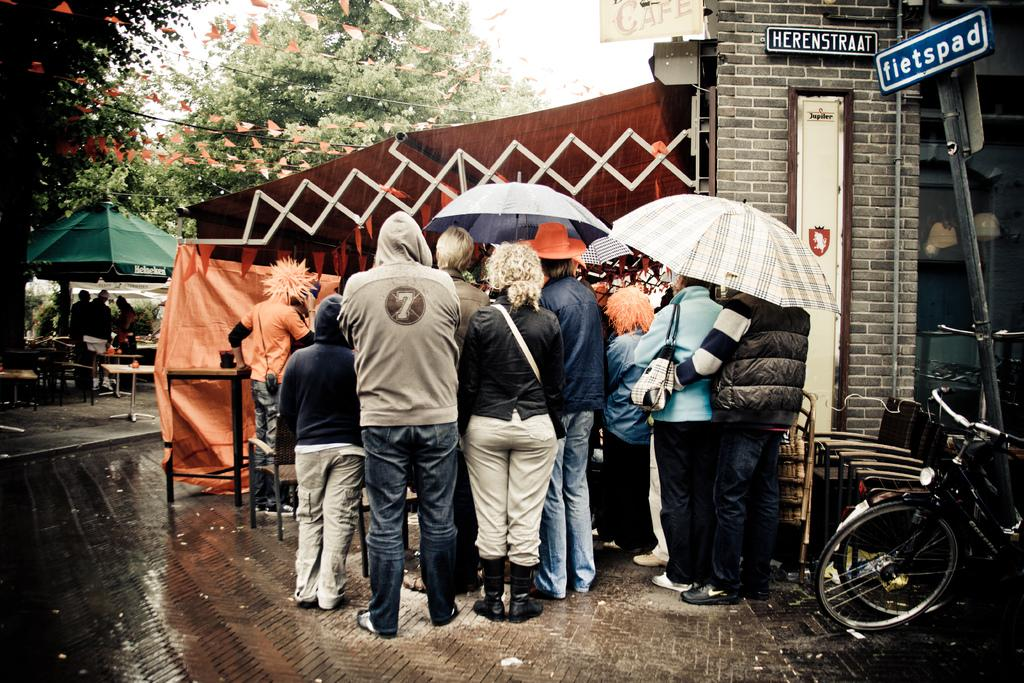What can be seen in the image? There are people, a bicycle, tents, umbrellas, name boards, a wall, various objects, and trees visible in the background. Can you describe the bicycle in the image? The bicycle is on the ground. What might the name boards be used for? The name boards might be used to identify or label specific areas or objects in the image. What is visible in the background of the image? Trees and the sky are visible in the background. What type of cub can be seen playing with the name boards in the image? There is no cub present in the image, and therefore no such activity can be observed. 